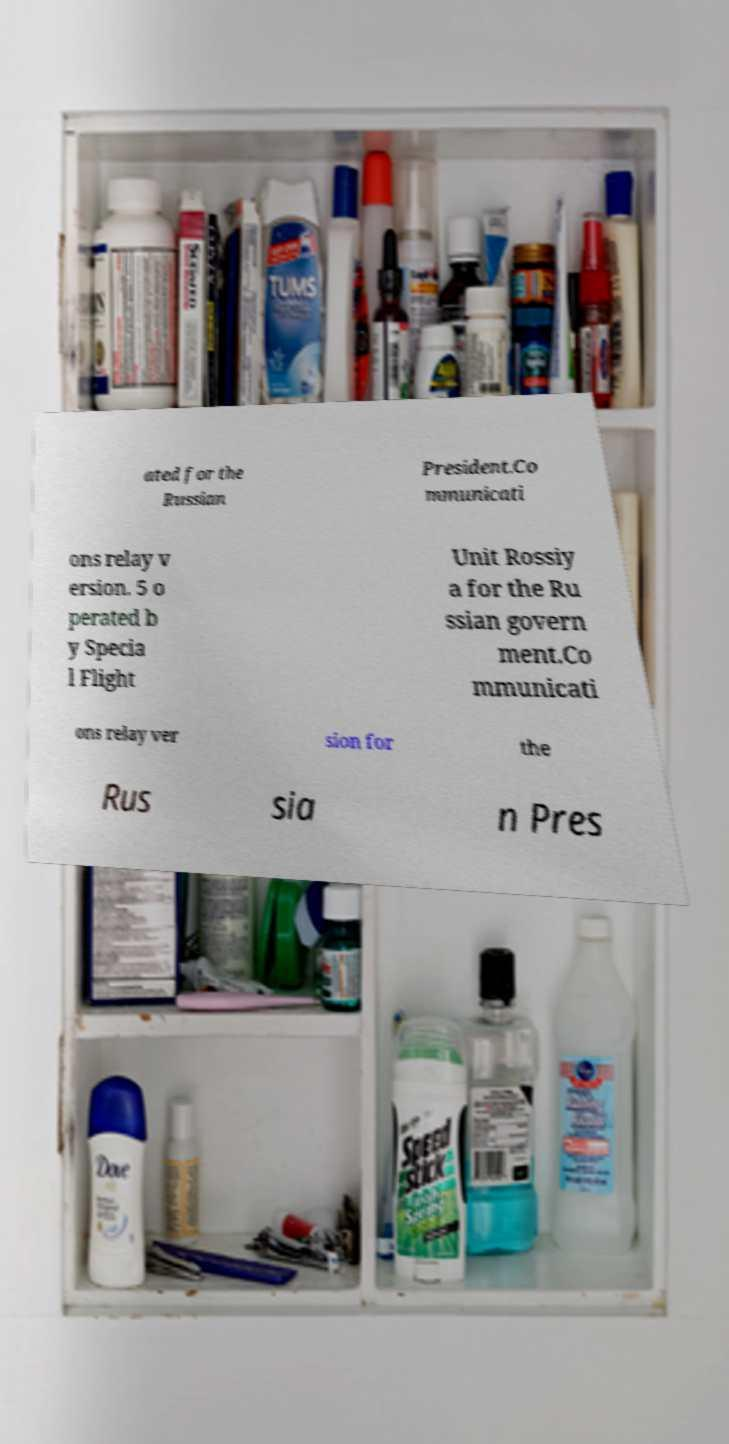Can you accurately transcribe the text from the provided image for me? ated for the Russian President.Co mmunicati ons relay v ersion. 5 o perated b y Specia l Flight Unit Rossiy a for the Ru ssian govern ment.Co mmunicati ons relay ver sion for the Rus sia n Pres 